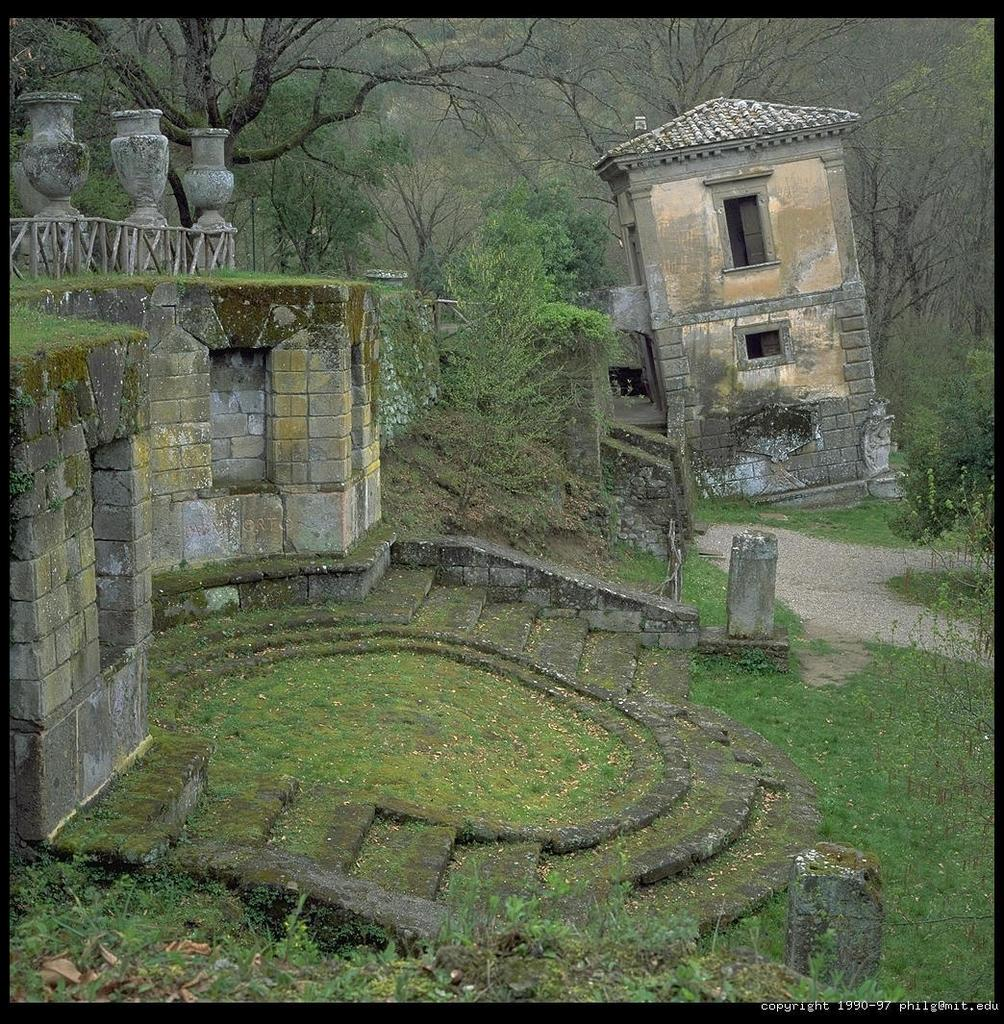What type of surface is visible in the image? There is ground visible in the image. What kind of vegetation is present on the ground? There is grass on the ground. What architectural feature can be seen in the image? There are stairs in the image. What type of structures are present in the image? There are buildings in the image. What safety feature is present in the image? There is a railing in the image. What type of trees are visible in the image, and what color are they? There are trees in the image, and they are green in color. What type of gate can be seen in the image? There is no gate present in the image. What attraction is visible in the image? There is no attraction present in the image. 